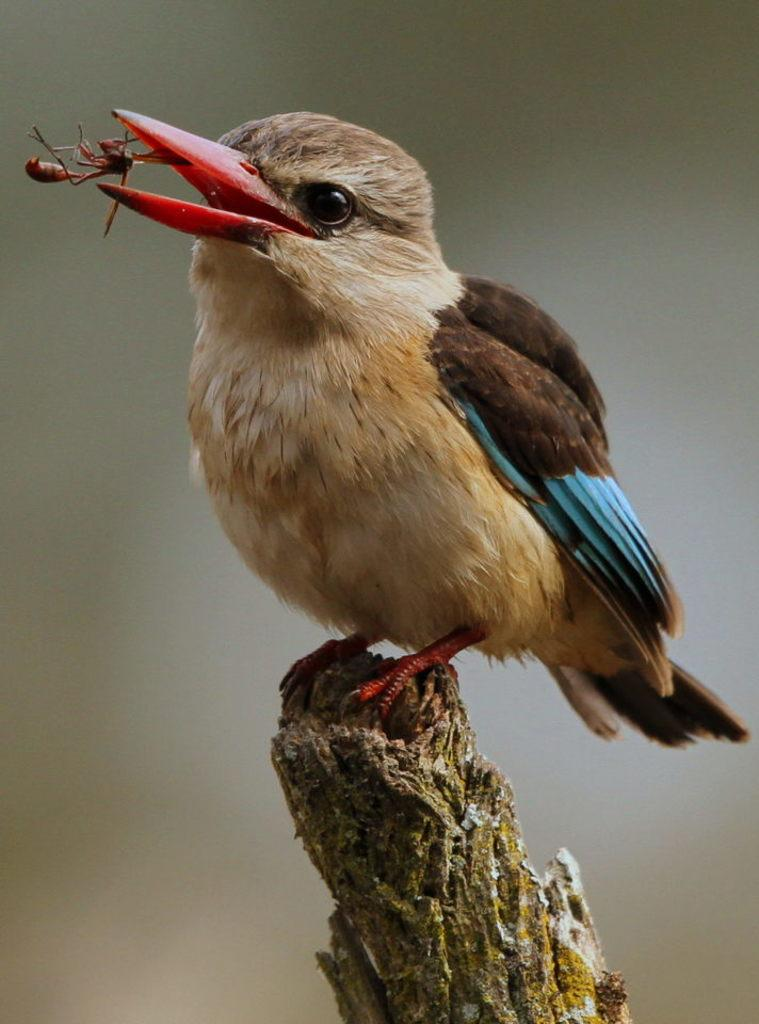What type of animal can be seen in the image? There is a bird in the image. What is the bird doing in the image? The bird has its mouth open. Where is the bird located in the image? The bird is on a branch of a tree. What is in the bird's mouth? There is an insect in the bird's mouth. Can you describe the background of the image? The background of the image is blurred. What type of toothpaste is the queen using in the image? There is no queen or toothpaste present in the image; it features a bird on a tree branch with an insect in its mouth. 